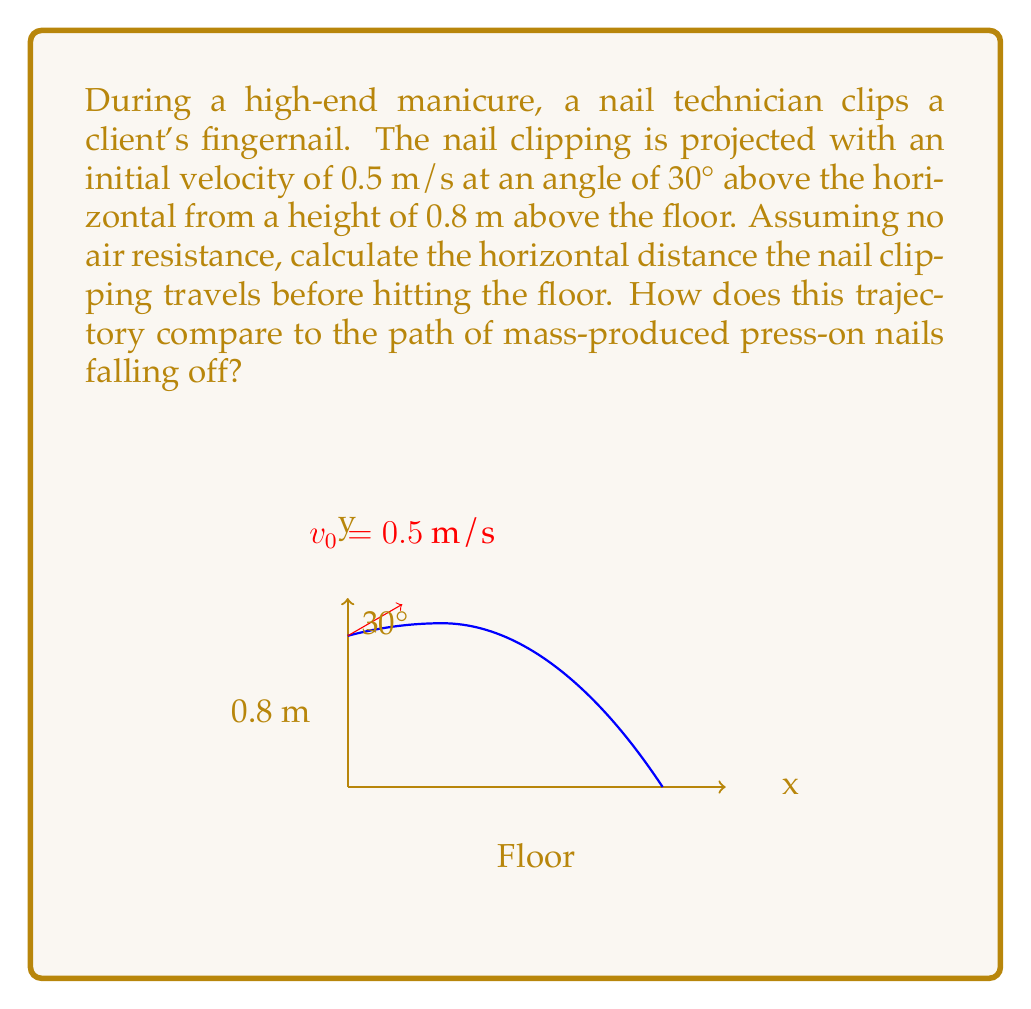Could you help me with this problem? Let's approach this step-by-step using projectile motion equations:

1) First, let's identify our known variables:
   - Initial velocity, $v_0 = 0.5$ m/s
   - Angle of projection, $\theta = 30°$
   - Initial height, $h_0 = 0.8$ m
   - Acceleration due to gravity, $g = 9.8$ m/s²

2) We need to find the time it takes for the nail clipping to hit the floor. We can use the vertical motion equation:

   $$y = h_0 + v_0 \sin(\theta)t - \frac{1}{2}gt^2$$

   At the point of impact, $y = 0$, so:

   $$0 = 0.8 + 0.5 \sin(30°)t - \frac{1}{2}(9.8)t^2$$

3) Simplify:
   $$0 = 0.8 + 0.25t - 4.9t^2$$
   $$4.9t^2 - 0.25t - 0.8 = 0$$

4) Solve this quadratic equation:
   $$t = \frac{0.25 \pm \sqrt{0.25^2 + 4(4.9)(0.8)}}{2(4.9)}$$
   $$t \approx 0.5307 \text{ s}$$ (positive root)

5) Now that we have the time, we can find the horizontal distance using:
   $$x = v_0 \cos(\theta)t$$
   $$x = 0.5 \cos(30°)(0.5307)$$
   $$x \approx 0.2298 \text{ m}$$

Compared to mass-produced press-on nails falling off, this trajectory is more precisely controlled. Press-on nails would likely fall straight down or in unpredictable patterns due to their shape and air resistance, lacking the initial velocity and angle of projection that a professional manicurist can impart to nail clippings.
Answer: $0.2298$ m 